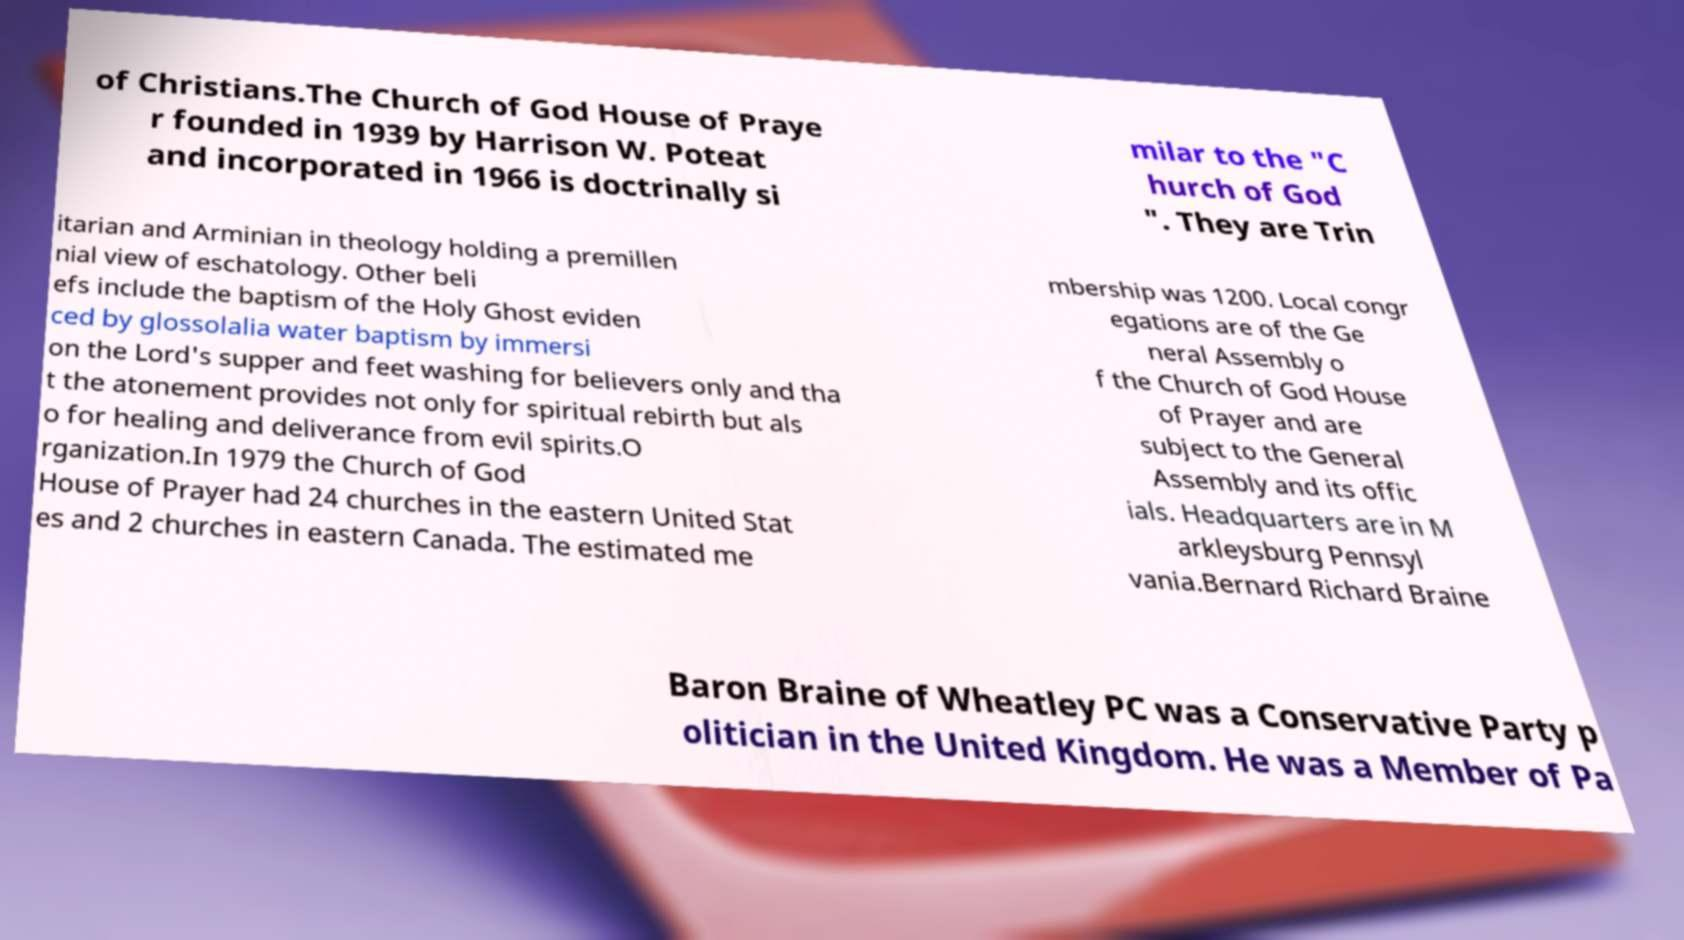Please read and relay the text visible in this image. What does it say? of Christians.The Church of God House of Praye r founded in 1939 by Harrison W. Poteat and incorporated in 1966 is doctrinally si milar to the "C hurch of God ". They are Trin itarian and Arminian in theology holding a premillen nial view of eschatology. Other beli efs include the baptism of the Holy Ghost eviden ced by glossolalia water baptism by immersi on the Lord's supper and feet washing for believers only and tha t the atonement provides not only for spiritual rebirth but als o for healing and deliverance from evil spirits.O rganization.In 1979 the Church of God House of Prayer had 24 churches in the eastern United Stat es and 2 churches in eastern Canada. The estimated me mbership was 1200. Local congr egations are of the Ge neral Assembly o f the Church of God House of Prayer and are subject to the General Assembly and its offic ials. Headquarters are in M arkleysburg Pennsyl vania.Bernard Richard Braine Baron Braine of Wheatley PC was a Conservative Party p olitician in the United Kingdom. He was a Member of Pa 